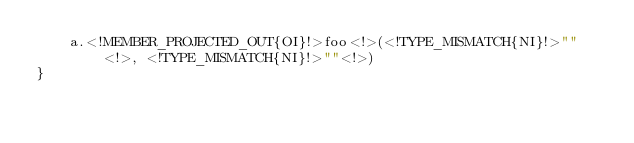Convert code to text. <code><loc_0><loc_0><loc_500><loc_500><_Kotlin_>    a.<!MEMBER_PROJECTED_OUT{OI}!>foo<!>(<!TYPE_MISMATCH{NI}!>""<!>, <!TYPE_MISMATCH{NI}!>""<!>)
}
</code> 